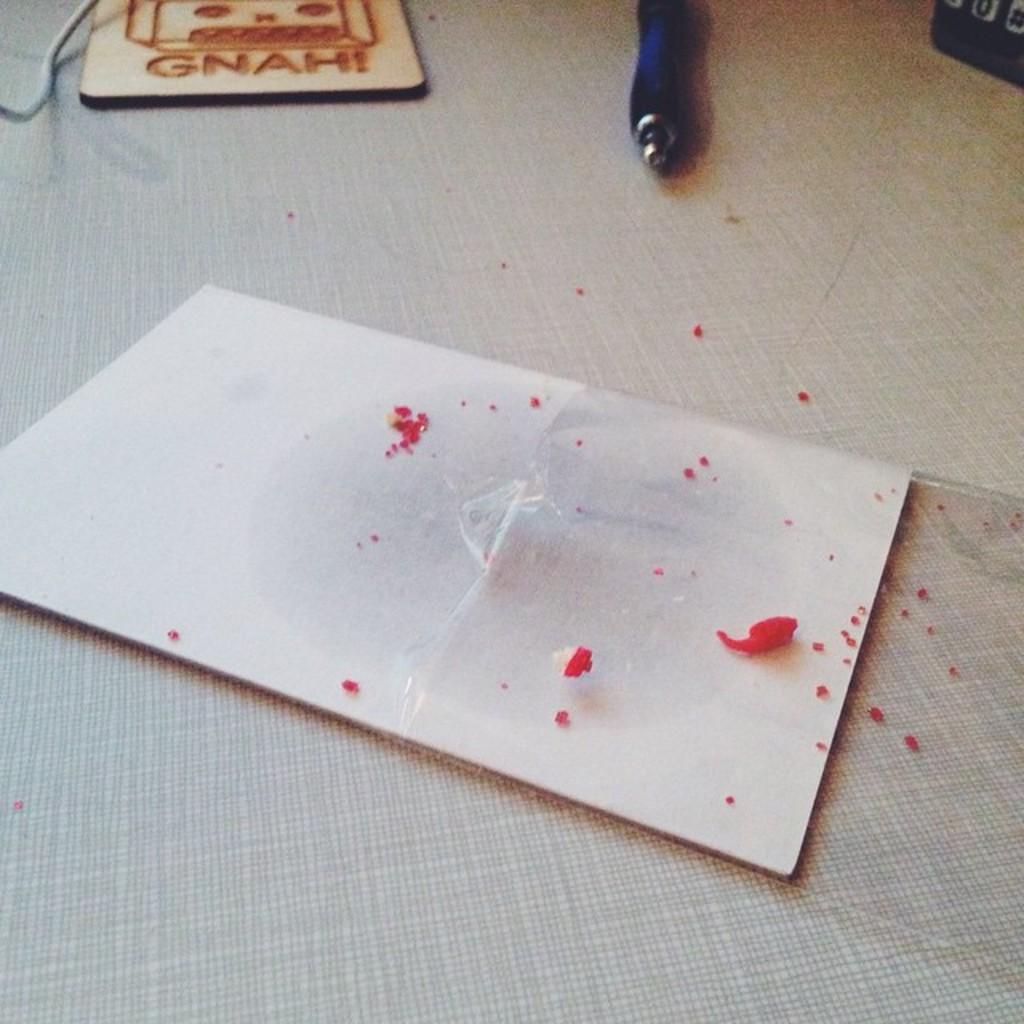What object can be seen in the image that is commonly used for writing? There is a pen in the image that is commonly used for writing. What type of surface is the pen placed on in the image? There is a wooden board in the image, and both the pen and the wooden board are on a table. What type of dirt can be seen on the wooden board in the image? There is no dirt visible on the wooden board in the image. How many people are attending the party in the image? There is no party depicted in the image. 